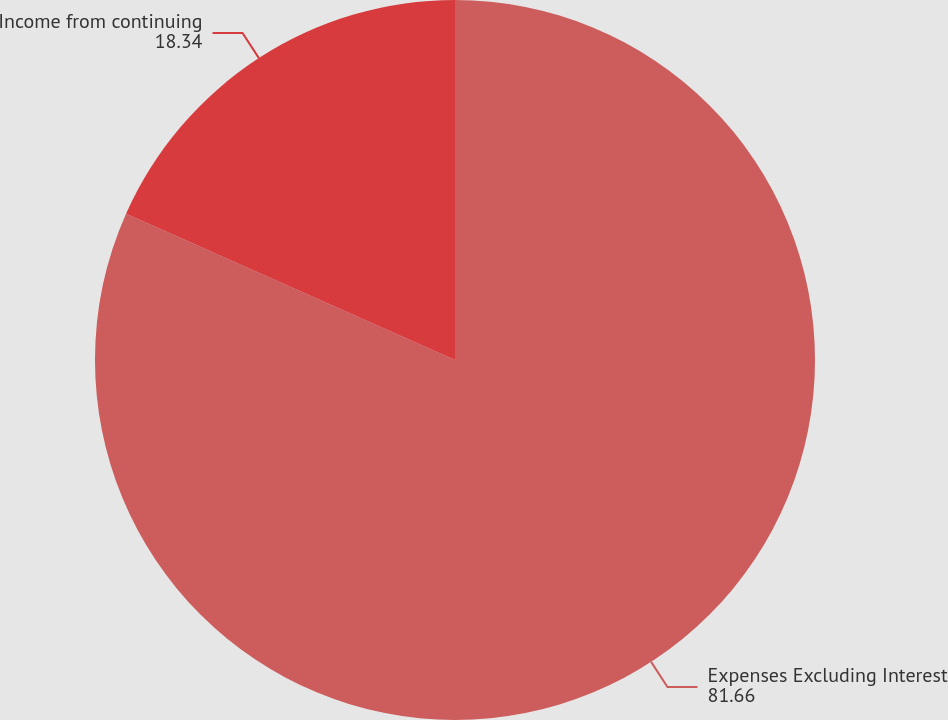Convert chart. <chart><loc_0><loc_0><loc_500><loc_500><pie_chart><fcel>Expenses Excluding Interest<fcel>Income from continuing<nl><fcel>81.66%<fcel>18.34%<nl></chart> 